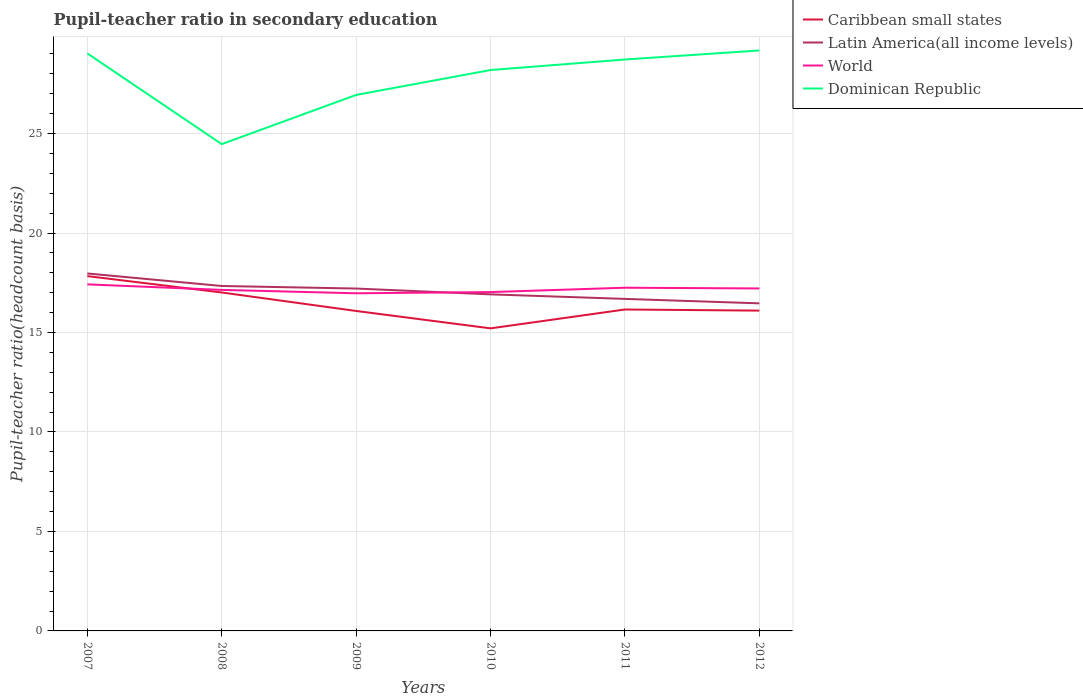Is the number of lines equal to the number of legend labels?
Provide a short and direct response. Yes. Across all years, what is the maximum pupil-teacher ratio in secondary education in Latin America(all income levels)?
Make the answer very short. 16.46. In which year was the pupil-teacher ratio in secondary education in Caribbean small states maximum?
Ensure brevity in your answer.  2010. What is the total pupil-teacher ratio in secondary education in Caribbean small states in the graph?
Offer a terse response. 0.06. What is the difference between the highest and the second highest pupil-teacher ratio in secondary education in Latin America(all income levels)?
Your answer should be very brief. 1.5. What is the difference between two consecutive major ticks on the Y-axis?
Your response must be concise. 5. Does the graph contain any zero values?
Your response must be concise. No. How many legend labels are there?
Provide a short and direct response. 4. How are the legend labels stacked?
Make the answer very short. Vertical. What is the title of the graph?
Your answer should be very brief. Pupil-teacher ratio in secondary education. What is the label or title of the Y-axis?
Offer a terse response. Pupil-teacher ratio(headcount basis). What is the Pupil-teacher ratio(headcount basis) of Caribbean small states in 2007?
Ensure brevity in your answer.  17.83. What is the Pupil-teacher ratio(headcount basis) of Latin America(all income levels) in 2007?
Give a very brief answer. 17.97. What is the Pupil-teacher ratio(headcount basis) of World in 2007?
Make the answer very short. 17.42. What is the Pupil-teacher ratio(headcount basis) in Dominican Republic in 2007?
Your answer should be very brief. 29.03. What is the Pupil-teacher ratio(headcount basis) of Caribbean small states in 2008?
Your answer should be very brief. 17.01. What is the Pupil-teacher ratio(headcount basis) of Latin America(all income levels) in 2008?
Your answer should be very brief. 17.34. What is the Pupil-teacher ratio(headcount basis) of World in 2008?
Your response must be concise. 17.14. What is the Pupil-teacher ratio(headcount basis) of Dominican Republic in 2008?
Your answer should be very brief. 24.47. What is the Pupil-teacher ratio(headcount basis) in Caribbean small states in 2009?
Your answer should be compact. 16.08. What is the Pupil-teacher ratio(headcount basis) in Latin America(all income levels) in 2009?
Provide a succinct answer. 17.21. What is the Pupil-teacher ratio(headcount basis) of World in 2009?
Keep it short and to the point. 16.97. What is the Pupil-teacher ratio(headcount basis) in Dominican Republic in 2009?
Offer a terse response. 26.94. What is the Pupil-teacher ratio(headcount basis) in Caribbean small states in 2010?
Provide a succinct answer. 15.21. What is the Pupil-teacher ratio(headcount basis) of Latin America(all income levels) in 2010?
Your response must be concise. 16.92. What is the Pupil-teacher ratio(headcount basis) in World in 2010?
Your answer should be very brief. 17.03. What is the Pupil-teacher ratio(headcount basis) of Dominican Republic in 2010?
Offer a very short reply. 28.19. What is the Pupil-teacher ratio(headcount basis) in Caribbean small states in 2011?
Keep it short and to the point. 16.16. What is the Pupil-teacher ratio(headcount basis) in Latin America(all income levels) in 2011?
Your answer should be very brief. 16.69. What is the Pupil-teacher ratio(headcount basis) in World in 2011?
Provide a short and direct response. 17.25. What is the Pupil-teacher ratio(headcount basis) of Dominican Republic in 2011?
Offer a very short reply. 28.72. What is the Pupil-teacher ratio(headcount basis) of Caribbean small states in 2012?
Give a very brief answer. 16.1. What is the Pupil-teacher ratio(headcount basis) in Latin America(all income levels) in 2012?
Provide a succinct answer. 16.46. What is the Pupil-teacher ratio(headcount basis) in World in 2012?
Give a very brief answer. 17.21. What is the Pupil-teacher ratio(headcount basis) of Dominican Republic in 2012?
Offer a very short reply. 29.18. Across all years, what is the maximum Pupil-teacher ratio(headcount basis) in Caribbean small states?
Provide a succinct answer. 17.83. Across all years, what is the maximum Pupil-teacher ratio(headcount basis) in Latin America(all income levels)?
Your answer should be very brief. 17.97. Across all years, what is the maximum Pupil-teacher ratio(headcount basis) in World?
Your response must be concise. 17.42. Across all years, what is the maximum Pupil-teacher ratio(headcount basis) in Dominican Republic?
Offer a very short reply. 29.18. Across all years, what is the minimum Pupil-teacher ratio(headcount basis) of Caribbean small states?
Offer a terse response. 15.21. Across all years, what is the minimum Pupil-teacher ratio(headcount basis) in Latin America(all income levels)?
Make the answer very short. 16.46. Across all years, what is the minimum Pupil-teacher ratio(headcount basis) in World?
Offer a very short reply. 16.97. Across all years, what is the minimum Pupil-teacher ratio(headcount basis) of Dominican Republic?
Your answer should be compact. 24.47. What is the total Pupil-teacher ratio(headcount basis) of Caribbean small states in the graph?
Offer a very short reply. 98.39. What is the total Pupil-teacher ratio(headcount basis) of Latin America(all income levels) in the graph?
Give a very brief answer. 102.59. What is the total Pupil-teacher ratio(headcount basis) in World in the graph?
Keep it short and to the point. 103.03. What is the total Pupil-teacher ratio(headcount basis) in Dominican Republic in the graph?
Offer a very short reply. 166.53. What is the difference between the Pupil-teacher ratio(headcount basis) of Caribbean small states in 2007 and that in 2008?
Give a very brief answer. 0.82. What is the difference between the Pupil-teacher ratio(headcount basis) in Latin America(all income levels) in 2007 and that in 2008?
Give a very brief answer. 0.63. What is the difference between the Pupil-teacher ratio(headcount basis) of World in 2007 and that in 2008?
Ensure brevity in your answer.  0.28. What is the difference between the Pupil-teacher ratio(headcount basis) of Dominican Republic in 2007 and that in 2008?
Your answer should be very brief. 4.56. What is the difference between the Pupil-teacher ratio(headcount basis) in Caribbean small states in 2007 and that in 2009?
Your response must be concise. 1.75. What is the difference between the Pupil-teacher ratio(headcount basis) of Latin America(all income levels) in 2007 and that in 2009?
Make the answer very short. 0.76. What is the difference between the Pupil-teacher ratio(headcount basis) in World in 2007 and that in 2009?
Ensure brevity in your answer.  0.45. What is the difference between the Pupil-teacher ratio(headcount basis) of Dominican Republic in 2007 and that in 2009?
Keep it short and to the point. 2.09. What is the difference between the Pupil-teacher ratio(headcount basis) of Caribbean small states in 2007 and that in 2010?
Make the answer very short. 2.63. What is the difference between the Pupil-teacher ratio(headcount basis) in Latin America(all income levels) in 2007 and that in 2010?
Give a very brief answer. 1.05. What is the difference between the Pupil-teacher ratio(headcount basis) in World in 2007 and that in 2010?
Make the answer very short. 0.39. What is the difference between the Pupil-teacher ratio(headcount basis) in Dominican Republic in 2007 and that in 2010?
Offer a terse response. 0.84. What is the difference between the Pupil-teacher ratio(headcount basis) of Caribbean small states in 2007 and that in 2011?
Provide a succinct answer. 1.68. What is the difference between the Pupil-teacher ratio(headcount basis) in Latin America(all income levels) in 2007 and that in 2011?
Ensure brevity in your answer.  1.28. What is the difference between the Pupil-teacher ratio(headcount basis) of World in 2007 and that in 2011?
Make the answer very short. 0.17. What is the difference between the Pupil-teacher ratio(headcount basis) in Dominican Republic in 2007 and that in 2011?
Provide a short and direct response. 0.31. What is the difference between the Pupil-teacher ratio(headcount basis) in Caribbean small states in 2007 and that in 2012?
Offer a very short reply. 1.74. What is the difference between the Pupil-teacher ratio(headcount basis) in Latin America(all income levels) in 2007 and that in 2012?
Offer a very short reply. 1.5. What is the difference between the Pupil-teacher ratio(headcount basis) of World in 2007 and that in 2012?
Provide a succinct answer. 0.21. What is the difference between the Pupil-teacher ratio(headcount basis) in Dominican Republic in 2007 and that in 2012?
Provide a short and direct response. -0.15. What is the difference between the Pupil-teacher ratio(headcount basis) of Caribbean small states in 2008 and that in 2009?
Your answer should be very brief. 0.93. What is the difference between the Pupil-teacher ratio(headcount basis) in Latin America(all income levels) in 2008 and that in 2009?
Your answer should be very brief. 0.13. What is the difference between the Pupil-teacher ratio(headcount basis) in World in 2008 and that in 2009?
Offer a terse response. 0.17. What is the difference between the Pupil-teacher ratio(headcount basis) of Dominican Republic in 2008 and that in 2009?
Your response must be concise. -2.47. What is the difference between the Pupil-teacher ratio(headcount basis) of Caribbean small states in 2008 and that in 2010?
Your answer should be compact. 1.8. What is the difference between the Pupil-teacher ratio(headcount basis) of Latin America(all income levels) in 2008 and that in 2010?
Make the answer very short. 0.42. What is the difference between the Pupil-teacher ratio(headcount basis) of World in 2008 and that in 2010?
Offer a terse response. 0.11. What is the difference between the Pupil-teacher ratio(headcount basis) in Dominican Republic in 2008 and that in 2010?
Make the answer very short. -3.72. What is the difference between the Pupil-teacher ratio(headcount basis) of Caribbean small states in 2008 and that in 2011?
Provide a short and direct response. 0.86. What is the difference between the Pupil-teacher ratio(headcount basis) of Latin America(all income levels) in 2008 and that in 2011?
Your answer should be compact. 0.65. What is the difference between the Pupil-teacher ratio(headcount basis) of World in 2008 and that in 2011?
Give a very brief answer. -0.11. What is the difference between the Pupil-teacher ratio(headcount basis) of Dominican Republic in 2008 and that in 2011?
Provide a short and direct response. -4.25. What is the difference between the Pupil-teacher ratio(headcount basis) of Caribbean small states in 2008 and that in 2012?
Offer a terse response. 0.91. What is the difference between the Pupil-teacher ratio(headcount basis) of Latin America(all income levels) in 2008 and that in 2012?
Provide a short and direct response. 0.87. What is the difference between the Pupil-teacher ratio(headcount basis) in World in 2008 and that in 2012?
Your answer should be compact. -0.07. What is the difference between the Pupil-teacher ratio(headcount basis) of Dominican Republic in 2008 and that in 2012?
Give a very brief answer. -4.71. What is the difference between the Pupil-teacher ratio(headcount basis) in Caribbean small states in 2009 and that in 2010?
Your answer should be very brief. 0.87. What is the difference between the Pupil-teacher ratio(headcount basis) in Latin America(all income levels) in 2009 and that in 2010?
Give a very brief answer. 0.29. What is the difference between the Pupil-teacher ratio(headcount basis) of World in 2009 and that in 2010?
Offer a terse response. -0.06. What is the difference between the Pupil-teacher ratio(headcount basis) of Dominican Republic in 2009 and that in 2010?
Provide a short and direct response. -1.25. What is the difference between the Pupil-teacher ratio(headcount basis) of Caribbean small states in 2009 and that in 2011?
Keep it short and to the point. -0.07. What is the difference between the Pupil-teacher ratio(headcount basis) in Latin America(all income levels) in 2009 and that in 2011?
Give a very brief answer. 0.52. What is the difference between the Pupil-teacher ratio(headcount basis) in World in 2009 and that in 2011?
Make the answer very short. -0.28. What is the difference between the Pupil-teacher ratio(headcount basis) of Dominican Republic in 2009 and that in 2011?
Keep it short and to the point. -1.78. What is the difference between the Pupil-teacher ratio(headcount basis) in Caribbean small states in 2009 and that in 2012?
Offer a very short reply. -0.02. What is the difference between the Pupil-teacher ratio(headcount basis) in Latin America(all income levels) in 2009 and that in 2012?
Provide a succinct answer. 0.74. What is the difference between the Pupil-teacher ratio(headcount basis) of World in 2009 and that in 2012?
Keep it short and to the point. -0.24. What is the difference between the Pupil-teacher ratio(headcount basis) of Dominican Republic in 2009 and that in 2012?
Make the answer very short. -2.23. What is the difference between the Pupil-teacher ratio(headcount basis) in Caribbean small states in 2010 and that in 2011?
Offer a very short reply. -0.95. What is the difference between the Pupil-teacher ratio(headcount basis) of Latin America(all income levels) in 2010 and that in 2011?
Offer a terse response. 0.23. What is the difference between the Pupil-teacher ratio(headcount basis) of World in 2010 and that in 2011?
Provide a short and direct response. -0.22. What is the difference between the Pupil-teacher ratio(headcount basis) of Dominican Republic in 2010 and that in 2011?
Give a very brief answer. -0.53. What is the difference between the Pupil-teacher ratio(headcount basis) of Caribbean small states in 2010 and that in 2012?
Keep it short and to the point. -0.89. What is the difference between the Pupil-teacher ratio(headcount basis) in Latin America(all income levels) in 2010 and that in 2012?
Give a very brief answer. 0.45. What is the difference between the Pupil-teacher ratio(headcount basis) in World in 2010 and that in 2012?
Ensure brevity in your answer.  -0.18. What is the difference between the Pupil-teacher ratio(headcount basis) in Dominican Republic in 2010 and that in 2012?
Give a very brief answer. -0.98. What is the difference between the Pupil-teacher ratio(headcount basis) of Caribbean small states in 2011 and that in 2012?
Provide a short and direct response. 0.06. What is the difference between the Pupil-teacher ratio(headcount basis) in Latin America(all income levels) in 2011 and that in 2012?
Offer a terse response. 0.22. What is the difference between the Pupil-teacher ratio(headcount basis) of World in 2011 and that in 2012?
Keep it short and to the point. 0.04. What is the difference between the Pupil-teacher ratio(headcount basis) of Dominican Republic in 2011 and that in 2012?
Offer a very short reply. -0.45. What is the difference between the Pupil-teacher ratio(headcount basis) of Caribbean small states in 2007 and the Pupil-teacher ratio(headcount basis) of Latin America(all income levels) in 2008?
Your response must be concise. 0.5. What is the difference between the Pupil-teacher ratio(headcount basis) in Caribbean small states in 2007 and the Pupil-teacher ratio(headcount basis) in World in 2008?
Provide a short and direct response. 0.69. What is the difference between the Pupil-teacher ratio(headcount basis) of Caribbean small states in 2007 and the Pupil-teacher ratio(headcount basis) of Dominican Republic in 2008?
Offer a terse response. -6.63. What is the difference between the Pupil-teacher ratio(headcount basis) of Latin America(all income levels) in 2007 and the Pupil-teacher ratio(headcount basis) of World in 2008?
Provide a succinct answer. 0.83. What is the difference between the Pupil-teacher ratio(headcount basis) in Latin America(all income levels) in 2007 and the Pupil-teacher ratio(headcount basis) in Dominican Republic in 2008?
Make the answer very short. -6.5. What is the difference between the Pupil-teacher ratio(headcount basis) in World in 2007 and the Pupil-teacher ratio(headcount basis) in Dominican Republic in 2008?
Your answer should be compact. -7.05. What is the difference between the Pupil-teacher ratio(headcount basis) in Caribbean small states in 2007 and the Pupil-teacher ratio(headcount basis) in Latin America(all income levels) in 2009?
Offer a very short reply. 0.63. What is the difference between the Pupil-teacher ratio(headcount basis) in Caribbean small states in 2007 and the Pupil-teacher ratio(headcount basis) in World in 2009?
Provide a succinct answer. 0.86. What is the difference between the Pupil-teacher ratio(headcount basis) in Caribbean small states in 2007 and the Pupil-teacher ratio(headcount basis) in Dominican Republic in 2009?
Ensure brevity in your answer.  -9.11. What is the difference between the Pupil-teacher ratio(headcount basis) of Latin America(all income levels) in 2007 and the Pupil-teacher ratio(headcount basis) of Dominican Republic in 2009?
Offer a very short reply. -8.97. What is the difference between the Pupil-teacher ratio(headcount basis) of World in 2007 and the Pupil-teacher ratio(headcount basis) of Dominican Republic in 2009?
Offer a terse response. -9.52. What is the difference between the Pupil-teacher ratio(headcount basis) of Caribbean small states in 2007 and the Pupil-teacher ratio(headcount basis) of Latin America(all income levels) in 2010?
Provide a succinct answer. 0.92. What is the difference between the Pupil-teacher ratio(headcount basis) of Caribbean small states in 2007 and the Pupil-teacher ratio(headcount basis) of World in 2010?
Your response must be concise. 0.8. What is the difference between the Pupil-teacher ratio(headcount basis) of Caribbean small states in 2007 and the Pupil-teacher ratio(headcount basis) of Dominican Republic in 2010?
Keep it short and to the point. -10.36. What is the difference between the Pupil-teacher ratio(headcount basis) of Latin America(all income levels) in 2007 and the Pupil-teacher ratio(headcount basis) of World in 2010?
Provide a succinct answer. 0.94. What is the difference between the Pupil-teacher ratio(headcount basis) of Latin America(all income levels) in 2007 and the Pupil-teacher ratio(headcount basis) of Dominican Republic in 2010?
Ensure brevity in your answer.  -10.23. What is the difference between the Pupil-teacher ratio(headcount basis) in World in 2007 and the Pupil-teacher ratio(headcount basis) in Dominican Republic in 2010?
Provide a short and direct response. -10.77. What is the difference between the Pupil-teacher ratio(headcount basis) of Caribbean small states in 2007 and the Pupil-teacher ratio(headcount basis) of Latin America(all income levels) in 2011?
Your response must be concise. 1.15. What is the difference between the Pupil-teacher ratio(headcount basis) of Caribbean small states in 2007 and the Pupil-teacher ratio(headcount basis) of World in 2011?
Provide a succinct answer. 0.58. What is the difference between the Pupil-teacher ratio(headcount basis) in Caribbean small states in 2007 and the Pupil-teacher ratio(headcount basis) in Dominican Republic in 2011?
Provide a short and direct response. -10.89. What is the difference between the Pupil-teacher ratio(headcount basis) in Latin America(all income levels) in 2007 and the Pupil-teacher ratio(headcount basis) in World in 2011?
Provide a short and direct response. 0.72. What is the difference between the Pupil-teacher ratio(headcount basis) of Latin America(all income levels) in 2007 and the Pupil-teacher ratio(headcount basis) of Dominican Republic in 2011?
Provide a succinct answer. -10.76. What is the difference between the Pupil-teacher ratio(headcount basis) of World in 2007 and the Pupil-teacher ratio(headcount basis) of Dominican Republic in 2011?
Ensure brevity in your answer.  -11.3. What is the difference between the Pupil-teacher ratio(headcount basis) of Caribbean small states in 2007 and the Pupil-teacher ratio(headcount basis) of Latin America(all income levels) in 2012?
Your answer should be compact. 1.37. What is the difference between the Pupil-teacher ratio(headcount basis) of Caribbean small states in 2007 and the Pupil-teacher ratio(headcount basis) of World in 2012?
Your response must be concise. 0.62. What is the difference between the Pupil-teacher ratio(headcount basis) in Caribbean small states in 2007 and the Pupil-teacher ratio(headcount basis) in Dominican Republic in 2012?
Ensure brevity in your answer.  -11.34. What is the difference between the Pupil-teacher ratio(headcount basis) in Latin America(all income levels) in 2007 and the Pupil-teacher ratio(headcount basis) in World in 2012?
Offer a terse response. 0.75. What is the difference between the Pupil-teacher ratio(headcount basis) in Latin America(all income levels) in 2007 and the Pupil-teacher ratio(headcount basis) in Dominican Republic in 2012?
Give a very brief answer. -11.21. What is the difference between the Pupil-teacher ratio(headcount basis) of World in 2007 and the Pupil-teacher ratio(headcount basis) of Dominican Republic in 2012?
Your response must be concise. -11.76. What is the difference between the Pupil-teacher ratio(headcount basis) in Caribbean small states in 2008 and the Pupil-teacher ratio(headcount basis) in Latin America(all income levels) in 2009?
Offer a terse response. -0.2. What is the difference between the Pupil-teacher ratio(headcount basis) in Caribbean small states in 2008 and the Pupil-teacher ratio(headcount basis) in World in 2009?
Your answer should be compact. 0.04. What is the difference between the Pupil-teacher ratio(headcount basis) in Caribbean small states in 2008 and the Pupil-teacher ratio(headcount basis) in Dominican Republic in 2009?
Your response must be concise. -9.93. What is the difference between the Pupil-teacher ratio(headcount basis) of Latin America(all income levels) in 2008 and the Pupil-teacher ratio(headcount basis) of World in 2009?
Your answer should be compact. 0.37. What is the difference between the Pupil-teacher ratio(headcount basis) in Latin America(all income levels) in 2008 and the Pupil-teacher ratio(headcount basis) in Dominican Republic in 2009?
Offer a terse response. -9.6. What is the difference between the Pupil-teacher ratio(headcount basis) of World in 2008 and the Pupil-teacher ratio(headcount basis) of Dominican Republic in 2009?
Your answer should be compact. -9.8. What is the difference between the Pupil-teacher ratio(headcount basis) in Caribbean small states in 2008 and the Pupil-teacher ratio(headcount basis) in Latin America(all income levels) in 2010?
Offer a very short reply. 0.09. What is the difference between the Pupil-teacher ratio(headcount basis) of Caribbean small states in 2008 and the Pupil-teacher ratio(headcount basis) of World in 2010?
Your answer should be compact. -0.02. What is the difference between the Pupil-teacher ratio(headcount basis) in Caribbean small states in 2008 and the Pupil-teacher ratio(headcount basis) in Dominican Republic in 2010?
Your response must be concise. -11.18. What is the difference between the Pupil-teacher ratio(headcount basis) of Latin America(all income levels) in 2008 and the Pupil-teacher ratio(headcount basis) of World in 2010?
Keep it short and to the point. 0.31. What is the difference between the Pupil-teacher ratio(headcount basis) of Latin America(all income levels) in 2008 and the Pupil-teacher ratio(headcount basis) of Dominican Republic in 2010?
Keep it short and to the point. -10.85. What is the difference between the Pupil-teacher ratio(headcount basis) in World in 2008 and the Pupil-teacher ratio(headcount basis) in Dominican Republic in 2010?
Keep it short and to the point. -11.05. What is the difference between the Pupil-teacher ratio(headcount basis) of Caribbean small states in 2008 and the Pupil-teacher ratio(headcount basis) of Latin America(all income levels) in 2011?
Keep it short and to the point. 0.32. What is the difference between the Pupil-teacher ratio(headcount basis) of Caribbean small states in 2008 and the Pupil-teacher ratio(headcount basis) of World in 2011?
Make the answer very short. -0.24. What is the difference between the Pupil-teacher ratio(headcount basis) in Caribbean small states in 2008 and the Pupil-teacher ratio(headcount basis) in Dominican Republic in 2011?
Your response must be concise. -11.71. What is the difference between the Pupil-teacher ratio(headcount basis) in Latin America(all income levels) in 2008 and the Pupil-teacher ratio(headcount basis) in World in 2011?
Your response must be concise. 0.09. What is the difference between the Pupil-teacher ratio(headcount basis) in Latin America(all income levels) in 2008 and the Pupil-teacher ratio(headcount basis) in Dominican Republic in 2011?
Offer a terse response. -11.38. What is the difference between the Pupil-teacher ratio(headcount basis) of World in 2008 and the Pupil-teacher ratio(headcount basis) of Dominican Republic in 2011?
Your answer should be very brief. -11.58. What is the difference between the Pupil-teacher ratio(headcount basis) of Caribbean small states in 2008 and the Pupil-teacher ratio(headcount basis) of Latin America(all income levels) in 2012?
Make the answer very short. 0.55. What is the difference between the Pupil-teacher ratio(headcount basis) in Caribbean small states in 2008 and the Pupil-teacher ratio(headcount basis) in World in 2012?
Give a very brief answer. -0.2. What is the difference between the Pupil-teacher ratio(headcount basis) of Caribbean small states in 2008 and the Pupil-teacher ratio(headcount basis) of Dominican Republic in 2012?
Ensure brevity in your answer.  -12.16. What is the difference between the Pupil-teacher ratio(headcount basis) in Latin America(all income levels) in 2008 and the Pupil-teacher ratio(headcount basis) in World in 2012?
Offer a terse response. 0.12. What is the difference between the Pupil-teacher ratio(headcount basis) in Latin America(all income levels) in 2008 and the Pupil-teacher ratio(headcount basis) in Dominican Republic in 2012?
Make the answer very short. -11.84. What is the difference between the Pupil-teacher ratio(headcount basis) of World in 2008 and the Pupil-teacher ratio(headcount basis) of Dominican Republic in 2012?
Make the answer very short. -12.03. What is the difference between the Pupil-teacher ratio(headcount basis) in Caribbean small states in 2009 and the Pupil-teacher ratio(headcount basis) in Latin America(all income levels) in 2010?
Give a very brief answer. -0.83. What is the difference between the Pupil-teacher ratio(headcount basis) in Caribbean small states in 2009 and the Pupil-teacher ratio(headcount basis) in World in 2010?
Keep it short and to the point. -0.95. What is the difference between the Pupil-teacher ratio(headcount basis) of Caribbean small states in 2009 and the Pupil-teacher ratio(headcount basis) of Dominican Republic in 2010?
Keep it short and to the point. -12.11. What is the difference between the Pupil-teacher ratio(headcount basis) of Latin America(all income levels) in 2009 and the Pupil-teacher ratio(headcount basis) of World in 2010?
Your answer should be compact. 0.18. What is the difference between the Pupil-teacher ratio(headcount basis) in Latin America(all income levels) in 2009 and the Pupil-teacher ratio(headcount basis) in Dominican Republic in 2010?
Your response must be concise. -10.98. What is the difference between the Pupil-teacher ratio(headcount basis) in World in 2009 and the Pupil-teacher ratio(headcount basis) in Dominican Republic in 2010?
Keep it short and to the point. -11.22. What is the difference between the Pupil-teacher ratio(headcount basis) of Caribbean small states in 2009 and the Pupil-teacher ratio(headcount basis) of Latin America(all income levels) in 2011?
Make the answer very short. -0.61. What is the difference between the Pupil-teacher ratio(headcount basis) of Caribbean small states in 2009 and the Pupil-teacher ratio(headcount basis) of World in 2011?
Your answer should be compact. -1.17. What is the difference between the Pupil-teacher ratio(headcount basis) of Caribbean small states in 2009 and the Pupil-teacher ratio(headcount basis) of Dominican Republic in 2011?
Offer a terse response. -12.64. What is the difference between the Pupil-teacher ratio(headcount basis) in Latin America(all income levels) in 2009 and the Pupil-teacher ratio(headcount basis) in World in 2011?
Make the answer very short. -0.04. What is the difference between the Pupil-teacher ratio(headcount basis) in Latin America(all income levels) in 2009 and the Pupil-teacher ratio(headcount basis) in Dominican Republic in 2011?
Offer a very short reply. -11.51. What is the difference between the Pupil-teacher ratio(headcount basis) in World in 2009 and the Pupil-teacher ratio(headcount basis) in Dominican Republic in 2011?
Your answer should be compact. -11.75. What is the difference between the Pupil-teacher ratio(headcount basis) in Caribbean small states in 2009 and the Pupil-teacher ratio(headcount basis) in Latin America(all income levels) in 2012?
Your answer should be very brief. -0.38. What is the difference between the Pupil-teacher ratio(headcount basis) of Caribbean small states in 2009 and the Pupil-teacher ratio(headcount basis) of World in 2012?
Give a very brief answer. -1.13. What is the difference between the Pupil-teacher ratio(headcount basis) of Caribbean small states in 2009 and the Pupil-teacher ratio(headcount basis) of Dominican Republic in 2012?
Your answer should be very brief. -13.09. What is the difference between the Pupil-teacher ratio(headcount basis) in Latin America(all income levels) in 2009 and the Pupil-teacher ratio(headcount basis) in World in 2012?
Ensure brevity in your answer.  -0. What is the difference between the Pupil-teacher ratio(headcount basis) in Latin America(all income levels) in 2009 and the Pupil-teacher ratio(headcount basis) in Dominican Republic in 2012?
Your response must be concise. -11.97. What is the difference between the Pupil-teacher ratio(headcount basis) in World in 2009 and the Pupil-teacher ratio(headcount basis) in Dominican Republic in 2012?
Ensure brevity in your answer.  -12.2. What is the difference between the Pupil-teacher ratio(headcount basis) in Caribbean small states in 2010 and the Pupil-teacher ratio(headcount basis) in Latin America(all income levels) in 2011?
Your answer should be very brief. -1.48. What is the difference between the Pupil-teacher ratio(headcount basis) in Caribbean small states in 2010 and the Pupil-teacher ratio(headcount basis) in World in 2011?
Your answer should be very brief. -2.04. What is the difference between the Pupil-teacher ratio(headcount basis) of Caribbean small states in 2010 and the Pupil-teacher ratio(headcount basis) of Dominican Republic in 2011?
Give a very brief answer. -13.51. What is the difference between the Pupil-teacher ratio(headcount basis) of Latin America(all income levels) in 2010 and the Pupil-teacher ratio(headcount basis) of World in 2011?
Offer a terse response. -0.33. What is the difference between the Pupil-teacher ratio(headcount basis) of Latin America(all income levels) in 2010 and the Pupil-teacher ratio(headcount basis) of Dominican Republic in 2011?
Offer a very short reply. -11.81. What is the difference between the Pupil-teacher ratio(headcount basis) in World in 2010 and the Pupil-teacher ratio(headcount basis) in Dominican Republic in 2011?
Give a very brief answer. -11.69. What is the difference between the Pupil-teacher ratio(headcount basis) in Caribbean small states in 2010 and the Pupil-teacher ratio(headcount basis) in Latin America(all income levels) in 2012?
Make the answer very short. -1.26. What is the difference between the Pupil-teacher ratio(headcount basis) in Caribbean small states in 2010 and the Pupil-teacher ratio(headcount basis) in World in 2012?
Give a very brief answer. -2.01. What is the difference between the Pupil-teacher ratio(headcount basis) of Caribbean small states in 2010 and the Pupil-teacher ratio(headcount basis) of Dominican Republic in 2012?
Keep it short and to the point. -13.97. What is the difference between the Pupil-teacher ratio(headcount basis) in Latin America(all income levels) in 2010 and the Pupil-teacher ratio(headcount basis) in World in 2012?
Provide a succinct answer. -0.3. What is the difference between the Pupil-teacher ratio(headcount basis) of Latin America(all income levels) in 2010 and the Pupil-teacher ratio(headcount basis) of Dominican Republic in 2012?
Your response must be concise. -12.26. What is the difference between the Pupil-teacher ratio(headcount basis) of World in 2010 and the Pupil-teacher ratio(headcount basis) of Dominican Republic in 2012?
Keep it short and to the point. -12.14. What is the difference between the Pupil-teacher ratio(headcount basis) of Caribbean small states in 2011 and the Pupil-teacher ratio(headcount basis) of Latin America(all income levels) in 2012?
Keep it short and to the point. -0.31. What is the difference between the Pupil-teacher ratio(headcount basis) of Caribbean small states in 2011 and the Pupil-teacher ratio(headcount basis) of World in 2012?
Provide a short and direct response. -1.06. What is the difference between the Pupil-teacher ratio(headcount basis) in Caribbean small states in 2011 and the Pupil-teacher ratio(headcount basis) in Dominican Republic in 2012?
Offer a very short reply. -13.02. What is the difference between the Pupil-teacher ratio(headcount basis) in Latin America(all income levels) in 2011 and the Pupil-teacher ratio(headcount basis) in World in 2012?
Your answer should be compact. -0.52. What is the difference between the Pupil-teacher ratio(headcount basis) of Latin America(all income levels) in 2011 and the Pupil-teacher ratio(headcount basis) of Dominican Republic in 2012?
Ensure brevity in your answer.  -12.49. What is the difference between the Pupil-teacher ratio(headcount basis) in World in 2011 and the Pupil-teacher ratio(headcount basis) in Dominican Republic in 2012?
Offer a terse response. -11.93. What is the average Pupil-teacher ratio(headcount basis) in Caribbean small states per year?
Offer a very short reply. 16.4. What is the average Pupil-teacher ratio(headcount basis) of Latin America(all income levels) per year?
Your response must be concise. 17.1. What is the average Pupil-teacher ratio(headcount basis) of World per year?
Your response must be concise. 17.17. What is the average Pupil-teacher ratio(headcount basis) of Dominican Republic per year?
Keep it short and to the point. 27.75. In the year 2007, what is the difference between the Pupil-teacher ratio(headcount basis) of Caribbean small states and Pupil-teacher ratio(headcount basis) of Latin America(all income levels)?
Your answer should be very brief. -0.13. In the year 2007, what is the difference between the Pupil-teacher ratio(headcount basis) in Caribbean small states and Pupil-teacher ratio(headcount basis) in World?
Offer a terse response. 0.41. In the year 2007, what is the difference between the Pupil-teacher ratio(headcount basis) in Caribbean small states and Pupil-teacher ratio(headcount basis) in Dominican Republic?
Keep it short and to the point. -11.19. In the year 2007, what is the difference between the Pupil-teacher ratio(headcount basis) in Latin America(all income levels) and Pupil-teacher ratio(headcount basis) in World?
Offer a terse response. 0.55. In the year 2007, what is the difference between the Pupil-teacher ratio(headcount basis) in Latin America(all income levels) and Pupil-teacher ratio(headcount basis) in Dominican Republic?
Your answer should be compact. -11.06. In the year 2007, what is the difference between the Pupil-teacher ratio(headcount basis) in World and Pupil-teacher ratio(headcount basis) in Dominican Republic?
Offer a terse response. -11.61. In the year 2008, what is the difference between the Pupil-teacher ratio(headcount basis) of Caribbean small states and Pupil-teacher ratio(headcount basis) of Latin America(all income levels)?
Offer a terse response. -0.33. In the year 2008, what is the difference between the Pupil-teacher ratio(headcount basis) in Caribbean small states and Pupil-teacher ratio(headcount basis) in World?
Your answer should be compact. -0.13. In the year 2008, what is the difference between the Pupil-teacher ratio(headcount basis) of Caribbean small states and Pupil-teacher ratio(headcount basis) of Dominican Republic?
Provide a succinct answer. -7.46. In the year 2008, what is the difference between the Pupil-teacher ratio(headcount basis) in Latin America(all income levels) and Pupil-teacher ratio(headcount basis) in World?
Your response must be concise. 0.2. In the year 2008, what is the difference between the Pupil-teacher ratio(headcount basis) in Latin America(all income levels) and Pupil-teacher ratio(headcount basis) in Dominican Republic?
Offer a terse response. -7.13. In the year 2008, what is the difference between the Pupil-teacher ratio(headcount basis) of World and Pupil-teacher ratio(headcount basis) of Dominican Republic?
Give a very brief answer. -7.33. In the year 2009, what is the difference between the Pupil-teacher ratio(headcount basis) in Caribbean small states and Pupil-teacher ratio(headcount basis) in Latin America(all income levels)?
Offer a terse response. -1.13. In the year 2009, what is the difference between the Pupil-teacher ratio(headcount basis) of Caribbean small states and Pupil-teacher ratio(headcount basis) of World?
Provide a short and direct response. -0.89. In the year 2009, what is the difference between the Pupil-teacher ratio(headcount basis) of Caribbean small states and Pupil-teacher ratio(headcount basis) of Dominican Republic?
Give a very brief answer. -10.86. In the year 2009, what is the difference between the Pupil-teacher ratio(headcount basis) in Latin America(all income levels) and Pupil-teacher ratio(headcount basis) in World?
Offer a very short reply. 0.24. In the year 2009, what is the difference between the Pupil-teacher ratio(headcount basis) in Latin America(all income levels) and Pupil-teacher ratio(headcount basis) in Dominican Republic?
Offer a very short reply. -9.73. In the year 2009, what is the difference between the Pupil-teacher ratio(headcount basis) in World and Pupil-teacher ratio(headcount basis) in Dominican Republic?
Your answer should be very brief. -9.97. In the year 2010, what is the difference between the Pupil-teacher ratio(headcount basis) of Caribbean small states and Pupil-teacher ratio(headcount basis) of Latin America(all income levels)?
Your answer should be very brief. -1.71. In the year 2010, what is the difference between the Pupil-teacher ratio(headcount basis) in Caribbean small states and Pupil-teacher ratio(headcount basis) in World?
Ensure brevity in your answer.  -1.82. In the year 2010, what is the difference between the Pupil-teacher ratio(headcount basis) of Caribbean small states and Pupil-teacher ratio(headcount basis) of Dominican Republic?
Make the answer very short. -12.98. In the year 2010, what is the difference between the Pupil-teacher ratio(headcount basis) in Latin America(all income levels) and Pupil-teacher ratio(headcount basis) in World?
Give a very brief answer. -0.11. In the year 2010, what is the difference between the Pupil-teacher ratio(headcount basis) of Latin America(all income levels) and Pupil-teacher ratio(headcount basis) of Dominican Republic?
Keep it short and to the point. -11.28. In the year 2010, what is the difference between the Pupil-teacher ratio(headcount basis) of World and Pupil-teacher ratio(headcount basis) of Dominican Republic?
Your response must be concise. -11.16. In the year 2011, what is the difference between the Pupil-teacher ratio(headcount basis) in Caribbean small states and Pupil-teacher ratio(headcount basis) in Latin America(all income levels)?
Offer a very short reply. -0.53. In the year 2011, what is the difference between the Pupil-teacher ratio(headcount basis) of Caribbean small states and Pupil-teacher ratio(headcount basis) of World?
Ensure brevity in your answer.  -1.09. In the year 2011, what is the difference between the Pupil-teacher ratio(headcount basis) in Caribbean small states and Pupil-teacher ratio(headcount basis) in Dominican Republic?
Offer a very short reply. -12.57. In the year 2011, what is the difference between the Pupil-teacher ratio(headcount basis) in Latin America(all income levels) and Pupil-teacher ratio(headcount basis) in World?
Give a very brief answer. -0.56. In the year 2011, what is the difference between the Pupil-teacher ratio(headcount basis) of Latin America(all income levels) and Pupil-teacher ratio(headcount basis) of Dominican Republic?
Offer a very short reply. -12.03. In the year 2011, what is the difference between the Pupil-teacher ratio(headcount basis) of World and Pupil-teacher ratio(headcount basis) of Dominican Republic?
Provide a succinct answer. -11.47. In the year 2012, what is the difference between the Pupil-teacher ratio(headcount basis) of Caribbean small states and Pupil-teacher ratio(headcount basis) of Latin America(all income levels)?
Make the answer very short. -0.37. In the year 2012, what is the difference between the Pupil-teacher ratio(headcount basis) of Caribbean small states and Pupil-teacher ratio(headcount basis) of World?
Provide a succinct answer. -1.11. In the year 2012, what is the difference between the Pupil-teacher ratio(headcount basis) in Caribbean small states and Pupil-teacher ratio(headcount basis) in Dominican Republic?
Provide a short and direct response. -13.08. In the year 2012, what is the difference between the Pupil-teacher ratio(headcount basis) of Latin America(all income levels) and Pupil-teacher ratio(headcount basis) of World?
Ensure brevity in your answer.  -0.75. In the year 2012, what is the difference between the Pupil-teacher ratio(headcount basis) of Latin America(all income levels) and Pupil-teacher ratio(headcount basis) of Dominican Republic?
Provide a succinct answer. -12.71. In the year 2012, what is the difference between the Pupil-teacher ratio(headcount basis) of World and Pupil-teacher ratio(headcount basis) of Dominican Republic?
Provide a short and direct response. -11.96. What is the ratio of the Pupil-teacher ratio(headcount basis) of Caribbean small states in 2007 to that in 2008?
Ensure brevity in your answer.  1.05. What is the ratio of the Pupil-teacher ratio(headcount basis) in Latin America(all income levels) in 2007 to that in 2008?
Offer a very short reply. 1.04. What is the ratio of the Pupil-teacher ratio(headcount basis) of World in 2007 to that in 2008?
Provide a short and direct response. 1.02. What is the ratio of the Pupil-teacher ratio(headcount basis) in Dominican Republic in 2007 to that in 2008?
Provide a short and direct response. 1.19. What is the ratio of the Pupil-teacher ratio(headcount basis) of Caribbean small states in 2007 to that in 2009?
Your answer should be very brief. 1.11. What is the ratio of the Pupil-teacher ratio(headcount basis) of Latin America(all income levels) in 2007 to that in 2009?
Make the answer very short. 1.04. What is the ratio of the Pupil-teacher ratio(headcount basis) in World in 2007 to that in 2009?
Offer a terse response. 1.03. What is the ratio of the Pupil-teacher ratio(headcount basis) in Dominican Republic in 2007 to that in 2009?
Make the answer very short. 1.08. What is the ratio of the Pupil-teacher ratio(headcount basis) of Caribbean small states in 2007 to that in 2010?
Make the answer very short. 1.17. What is the ratio of the Pupil-teacher ratio(headcount basis) in Latin America(all income levels) in 2007 to that in 2010?
Keep it short and to the point. 1.06. What is the ratio of the Pupil-teacher ratio(headcount basis) in World in 2007 to that in 2010?
Ensure brevity in your answer.  1.02. What is the ratio of the Pupil-teacher ratio(headcount basis) in Dominican Republic in 2007 to that in 2010?
Offer a terse response. 1.03. What is the ratio of the Pupil-teacher ratio(headcount basis) in Caribbean small states in 2007 to that in 2011?
Your response must be concise. 1.1. What is the ratio of the Pupil-teacher ratio(headcount basis) in Latin America(all income levels) in 2007 to that in 2011?
Your answer should be compact. 1.08. What is the ratio of the Pupil-teacher ratio(headcount basis) in World in 2007 to that in 2011?
Keep it short and to the point. 1.01. What is the ratio of the Pupil-teacher ratio(headcount basis) of Dominican Republic in 2007 to that in 2011?
Ensure brevity in your answer.  1.01. What is the ratio of the Pupil-teacher ratio(headcount basis) of Caribbean small states in 2007 to that in 2012?
Provide a short and direct response. 1.11. What is the ratio of the Pupil-teacher ratio(headcount basis) in Latin America(all income levels) in 2007 to that in 2012?
Your answer should be very brief. 1.09. What is the ratio of the Pupil-teacher ratio(headcount basis) of Caribbean small states in 2008 to that in 2009?
Offer a very short reply. 1.06. What is the ratio of the Pupil-teacher ratio(headcount basis) in Latin America(all income levels) in 2008 to that in 2009?
Provide a short and direct response. 1.01. What is the ratio of the Pupil-teacher ratio(headcount basis) of Dominican Republic in 2008 to that in 2009?
Your answer should be compact. 0.91. What is the ratio of the Pupil-teacher ratio(headcount basis) of Caribbean small states in 2008 to that in 2010?
Provide a succinct answer. 1.12. What is the ratio of the Pupil-teacher ratio(headcount basis) of Latin America(all income levels) in 2008 to that in 2010?
Offer a very short reply. 1.02. What is the ratio of the Pupil-teacher ratio(headcount basis) of Dominican Republic in 2008 to that in 2010?
Your answer should be very brief. 0.87. What is the ratio of the Pupil-teacher ratio(headcount basis) of Caribbean small states in 2008 to that in 2011?
Offer a terse response. 1.05. What is the ratio of the Pupil-teacher ratio(headcount basis) in Latin America(all income levels) in 2008 to that in 2011?
Make the answer very short. 1.04. What is the ratio of the Pupil-teacher ratio(headcount basis) of World in 2008 to that in 2011?
Offer a terse response. 0.99. What is the ratio of the Pupil-teacher ratio(headcount basis) in Dominican Republic in 2008 to that in 2011?
Keep it short and to the point. 0.85. What is the ratio of the Pupil-teacher ratio(headcount basis) of Caribbean small states in 2008 to that in 2012?
Provide a succinct answer. 1.06. What is the ratio of the Pupil-teacher ratio(headcount basis) in Latin America(all income levels) in 2008 to that in 2012?
Offer a terse response. 1.05. What is the ratio of the Pupil-teacher ratio(headcount basis) in Dominican Republic in 2008 to that in 2012?
Make the answer very short. 0.84. What is the ratio of the Pupil-teacher ratio(headcount basis) of Caribbean small states in 2009 to that in 2010?
Ensure brevity in your answer.  1.06. What is the ratio of the Pupil-teacher ratio(headcount basis) of Latin America(all income levels) in 2009 to that in 2010?
Provide a succinct answer. 1.02. What is the ratio of the Pupil-teacher ratio(headcount basis) of Dominican Republic in 2009 to that in 2010?
Provide a short and direct response. 0.96. What is the ratio of the Pupil-teacher ratio(headcount basis) of Caribbean small states in 2009 to that in 2011?
Keep it short and to the point. 1. What is the ratio of the Pupil-teacher ratio(headcount basis) of Latin America(all income levels) in 2009 to that in 2011?
Your answer should be compact. 1.03. What is the ratio of the Pupil-teacher ratio(headcount basis) of World in 2009 to that in 2011?
Offer a terse response. 0.98. What is the ratio of the Pupil-teacher ratio(headcount basis) in Dominican Republic in 2009 to that in 2011?
Your response must be concise. 0.94. What is the ratio of the Pupil-teacher ratio(headcount basis) of Caribbean small states in 2009 to that in 2012?
Ensure brevity in your answer.  1. What is the ratio of the Pupil-teacher ratio(headcount basis) in Latin America(all income levels) in 2009 to that in 2012?
Give a very brief answer. 1.05. What is the ratio of the Pupil-teacher ratio(headcount basis) in World in 2009 to that in 2012?
Give a very brief answer. 0.99. What is the ratio of the Pupil-teacher ratio(headcount basis) of Dominican Republic in 2009 to that in 2012?
Offer a very short reply. 0.92. What is the ratio of the Pupil-teacher ratio(headcount basis) of Caribbean small states in 2010 to that in 2011?
Offer a terse response. 0.94. What is the ratio of the Pupil-teacher ratio(headcount basis) in Latin America(all income levels) in 2010 to that in 2011?
Your answer should be compact. 1.01. What is the ratio of the Pupil-teacher ratio(headcount basis) in World in 2010 to that in 2011?
Your response must be concise. 0.99. What is the ratio of the Pupil-teacher ratio(headcount basis) in Dominican Republic in 2010 to that in 2011?
Offer a very short reply. 0.98. What is the ratio of the Pupil-teacher ratio(headcount basis) of Caribbean small states in 2010 to that in 2012?
Provide a succinct answer. 0.94. What is the ratio of the Pupil-teacher ratio(headcount basis) of Latin America(all income levels) in 2010 to that in 2012?
Make the answer very short. 1.03. What is the ratio of the Pupil-teacher ratio(headcount basis) in Dominican Republic in 2010 to that in 2012?
Your answer should be compact. 0.97. What is the ratio of the Pupil-teacher ratio(headcount basis) in Caribbean small states in 2011 to that in 2012?
Offer a terse response. 1. What is the ratio of the Pupil-teacher ratio(headcount basis) in Latin America(all income levels) in 2011 to that in 2012?
Offer a terse response. 1.01. What is the ratio of the Pupil-teacher ratio(headcount basis) in Dominican Republic in 2011 to that in 2012?
Keep it short and to the point. 0.98. What is the difference between the highest and the second highest Pupil-teacher ratio(headcount basis) of Caribbean small states?
Your response must be concise. 0.82. What is the difference between the highest and the second highest Pupil-teacher ratio(headcount basis) in Latin America(all income levels)?
Offer a very short reply. 0.63. What is the difference between the highest and the second highest Pupil-teacher ratio(headcount basis) of World?
Offer a very short reply. 0.17. What is the difference between the highest and the second highest Pupil-teacher ratio(headcount basis) of Dominican Republic?
Your answer should be compact. 0.15. What is the difference between the highest and the lowest Pupil-teacher ratio(headcount basis) in Caribbean small states?
Ensure brevity in your answer.  2.63. What is the difference between the highest and the lowest Pupil-teacher ratio(headcount basis) of Latin America(all income levels)?
Provide a succinct answer. 1.5. What is the difference between the highest and the lowest Pupil-teacher ratio(headcount basis) of World?
Give a very brief answer. 0.45. What is the difference between the highest and the lowest Pupil-teacher ratio(headcount basis) in Dominican Republic?
Provide a succinct answer. 4.71. 